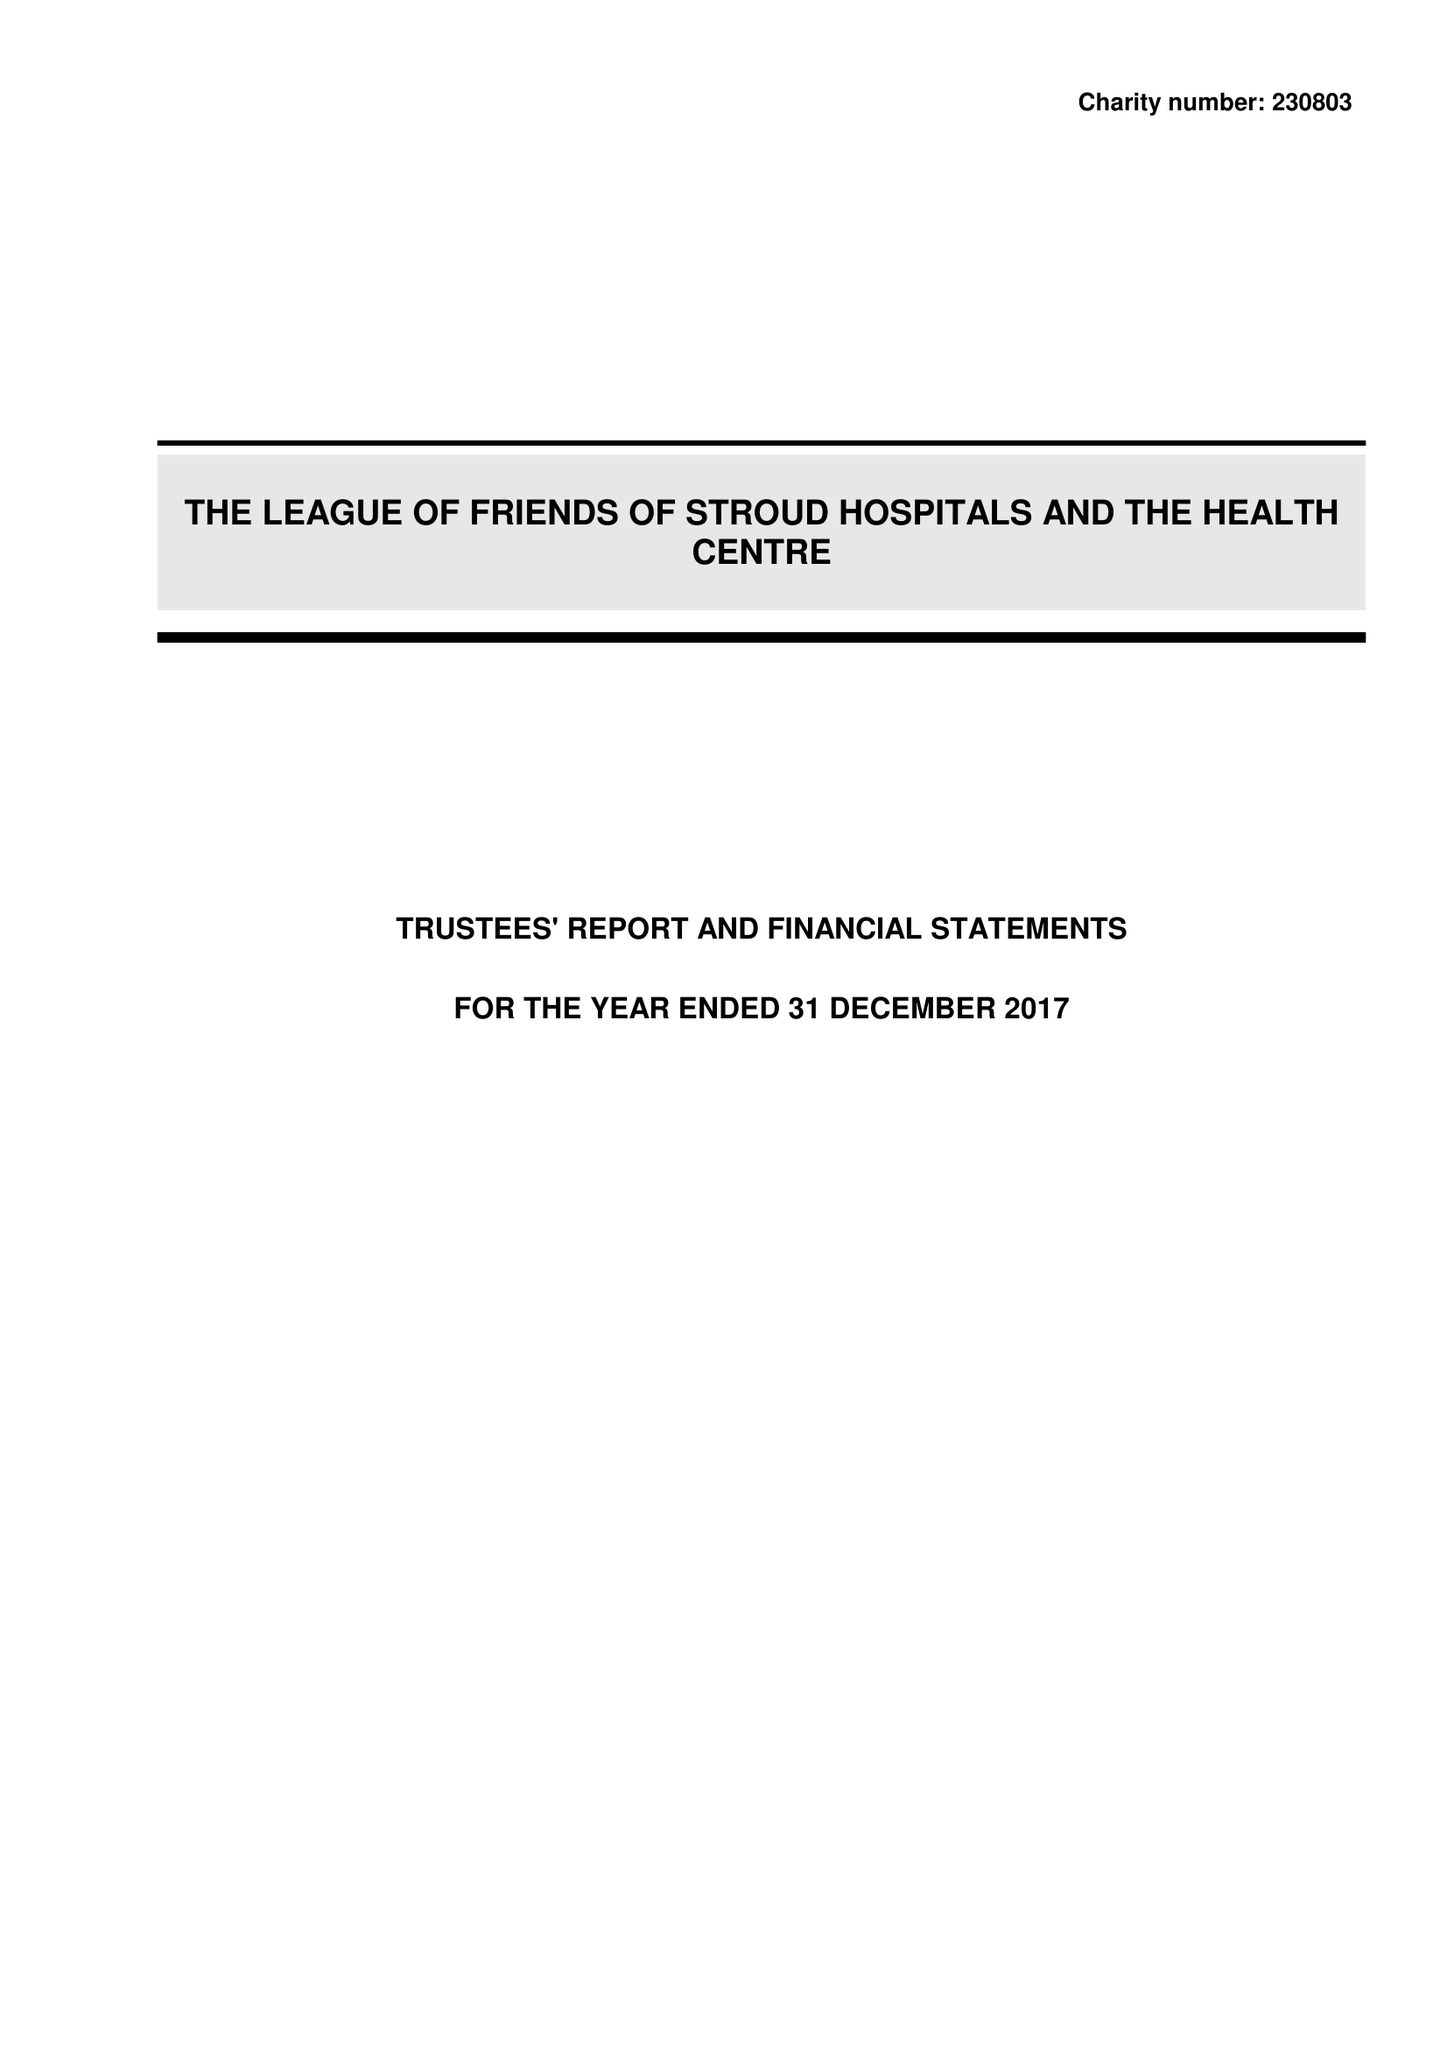What is the value for the address__post_town?
Answer the question using a single word or phrase. STROUD 